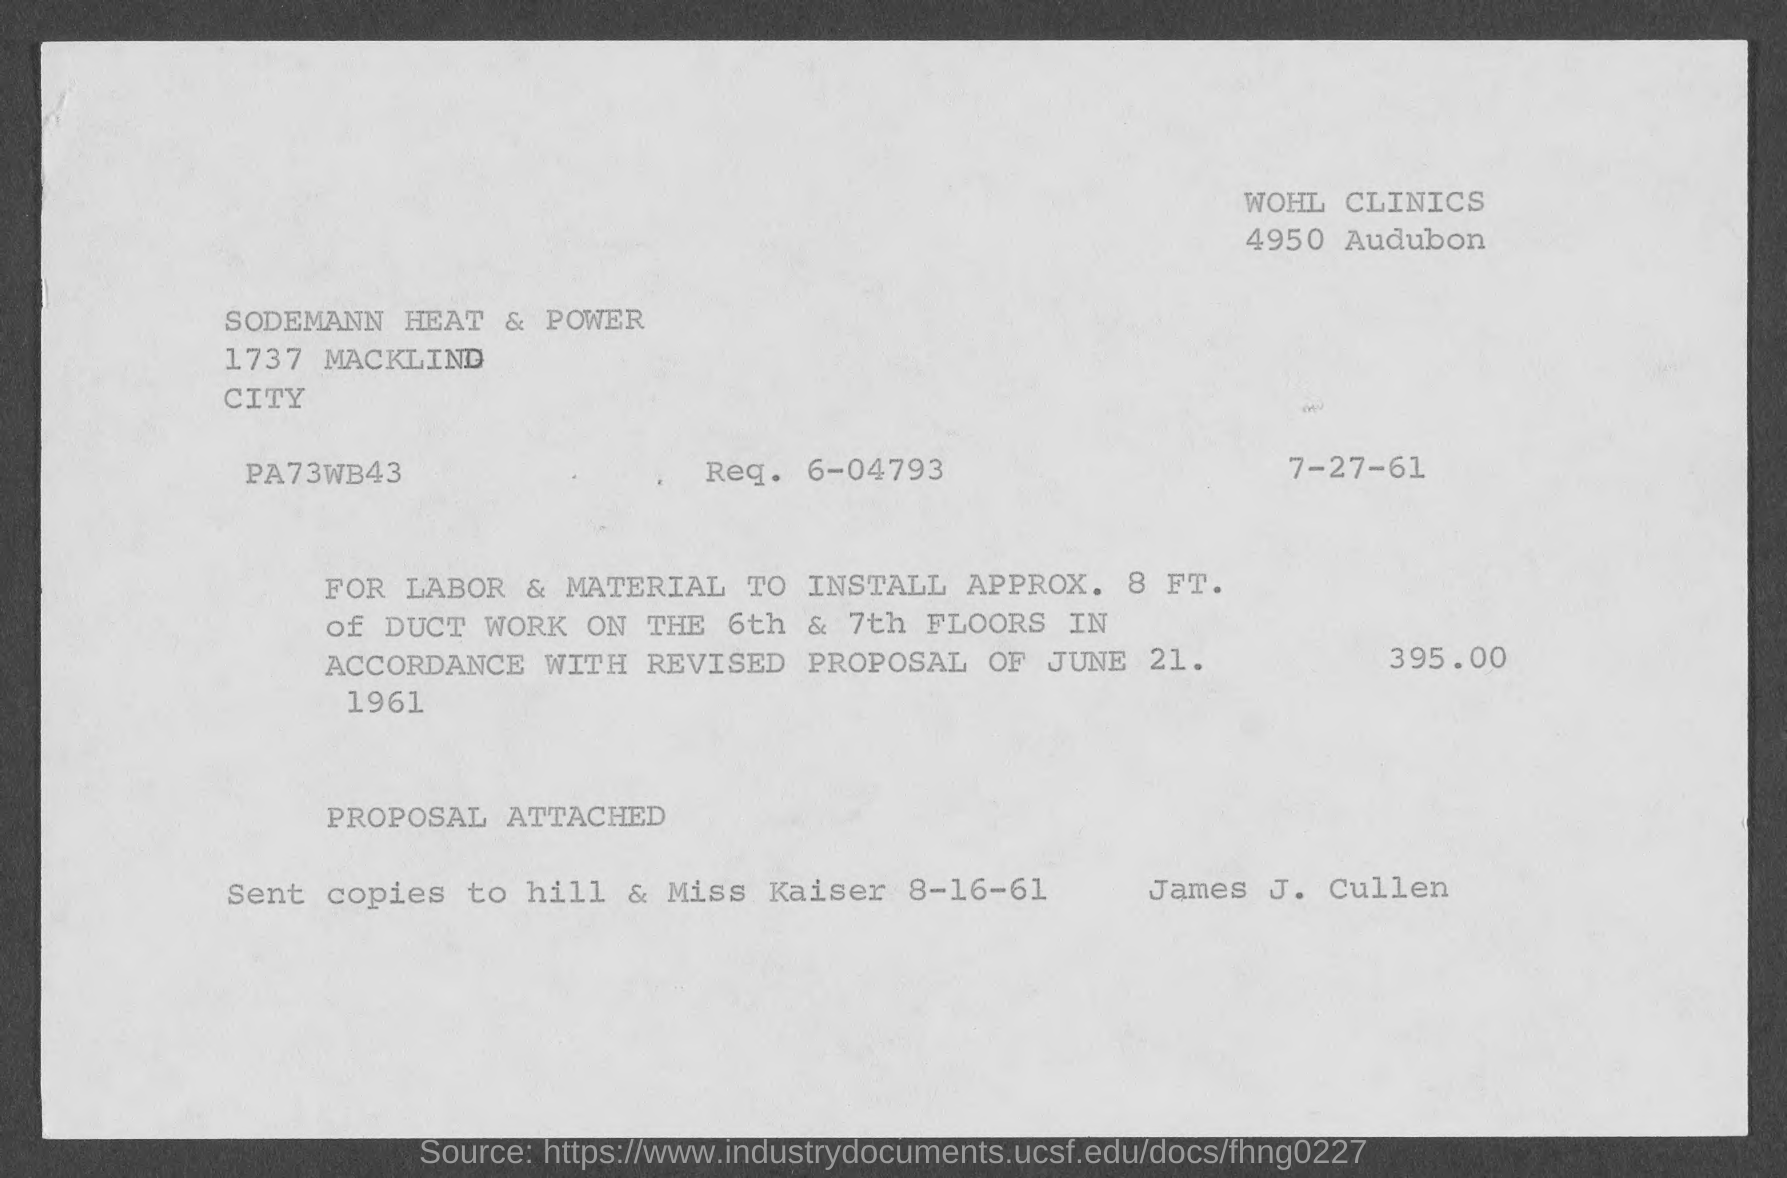What is the req. no?
Give a very brief answer. 6-04793. 